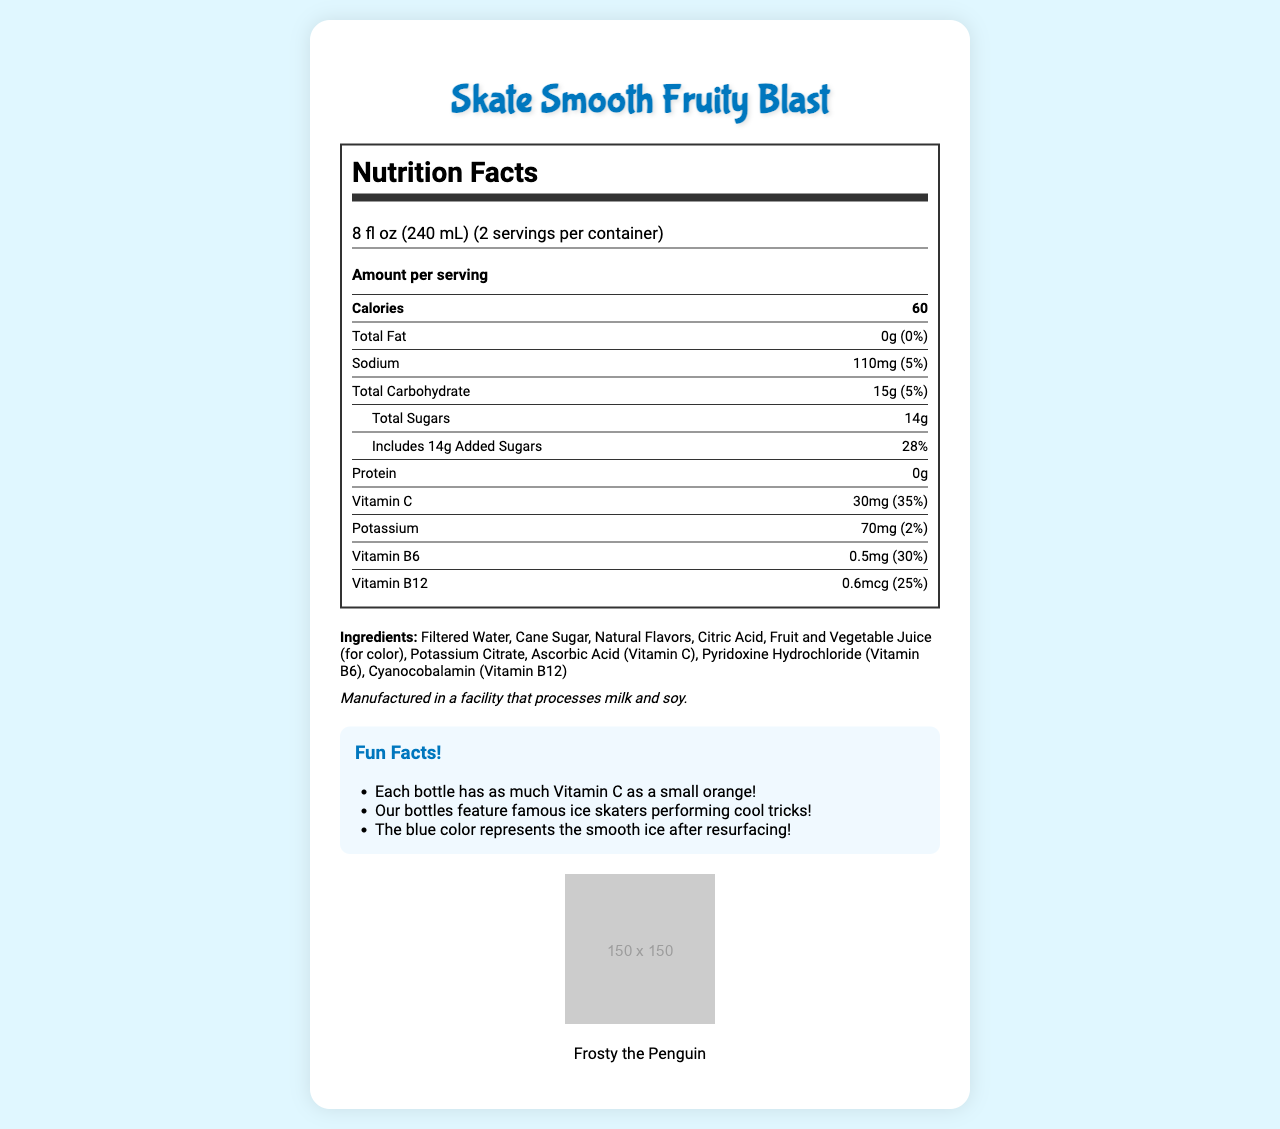what is the serving size? The document states that the serving size is 8 fl oz (240 mL).
Answer: 8 fl oz (240 mL) how many calories are in one serving? The document indicates that each serving has 60 calories.
Answer: 60 what percentage of the daily value of vitamin C does this drink provide per serving? The document lists that each serving provides 35% of the daily value for vitamin C.
Answer: 35% how much sodium is in a serving of this drink? According to the document, each serving contains 110mg of sodium.
Answer: 110mg list one ingredient found in the drink? The document includes a list of ingredients, and Filtered Water is one of them.
Answer: Filtered Water how many grams of total sugars are in the drink per serving? The document specifies that there are 14g of total sugars per serving.
Answer: 14g What fun fact can be found about the drink's vitamin content? The document has a section on fun facts, and one of them mentions that each bottle has as much Vitamin C as a small orange.
Answer: Each bottle has as much Vitamin C as a small orange! which famous cartoon character is the drink's mascot? A. Mickey Mouse B. Frosty the Penguin C. SpongeBob SquarePants The document mentions that Frosty the Penguin is the mascot.
Answer: B which element is not shown in the package graphics? A. Ice skater performing a spiral B. Zamboni smoothing the ice C. Polar bear playing hockey The document lists the package graphics, and a polar bear playing hockey is not one of them.
Answer: C does the drink contain protein? The document indicates that there is 0g of protein in the drink.
Answer: No Summarize the main idea of the document. This summary captures the essence of the document, covering the nutritional facts, ingredients, fun facts, and branding details.
Answer: The document is a nutrition facts label for a fruity sports drink called "Skate Smooth Fruity Blast," detailing its nutritional content, ingredients, fun facts, and packaging graphics. how much potassium is there per serving of the drink? The document specifies that each serving contains 70mg of potassium.
Answer: 70mg what is the daily value of total fat in the drink? A. 1% B. 0% C. 5% D. 10% The document shows that the total fat daily value is 0%.
Answer: B how many servings are in each container? The document states that there are 2 servings per container.
Answer: 2 what percentage of the daily value of sodium does one serving of this drink provide? The document indicates that one serving provides 5% of the daily value of sodium.
Answer: 5% what color does the drink's bottle represent? The document contains a fun fact stating this color representation.
Answer: The blue color represents the smooth ice after resurfacing. what is the daily value of added sugars in one serving? According to the document, one serving has 28% of the daily value for added sugars.
Answer: 28% which vitamin in the drink has the highest daily value percentage per serving? A. Vitamin C B. Vitamin B6 C. Vitamin B12 The document shows that Vitamin C has the highest daily value percentage per serving at 35%.
Answer: A what is the manufacturer's allergen warning? The document specifies this information under the allergen info section.
Answer: Manufactured in a facility that processes milk and soy. can you determine the price of the drink from this document? The document does not provide any pricing details.
Answer: Not enough information what is the total carbohydrate content per serving? The document lists the total carbohydrate content per serving as 15g.
Answer: 15g 